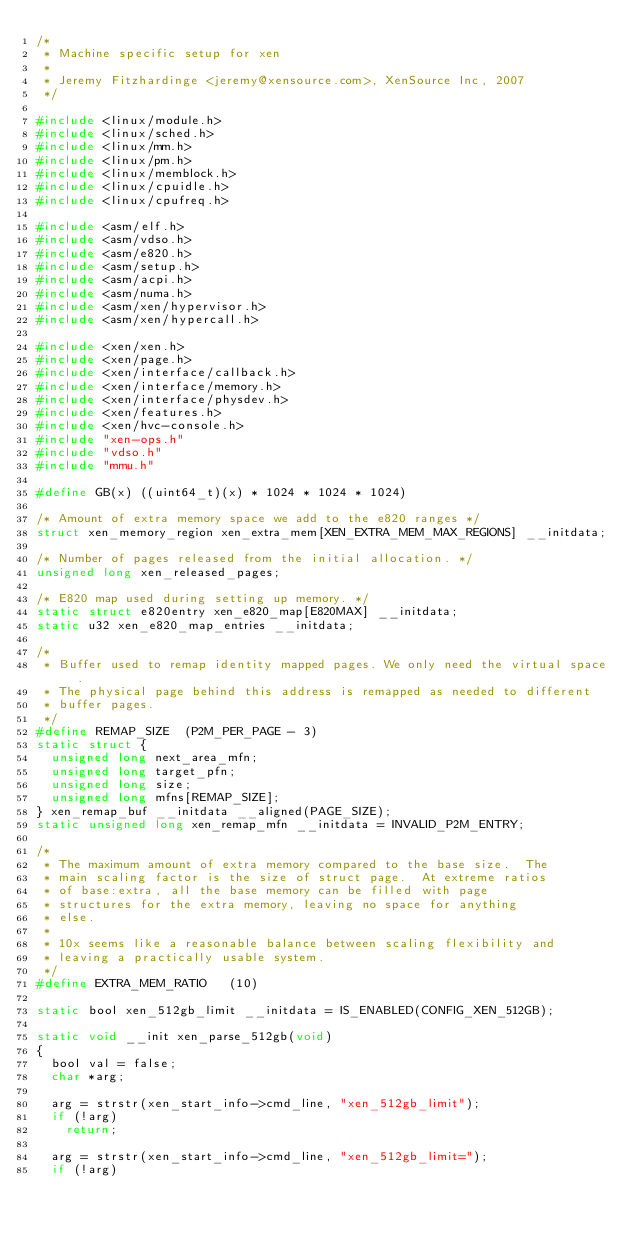Convert code to text. <code><loc_0><loc_0><loc_500><loc_500><_C_>/*
 * Machine specific setup for xen
 *
 * Jeremy Fitzhardinge <jeremy@xensource.com>, XenSource Inc, 2007
 */

#include <linux/module.h>
#include <linux/sched.h>
#include <linux/mm.h>
#include <linux/pm.h>
#include <linux/memblock.h>
#include <linux/cpuidle.h>
#include <linux/cpufreq.h>

#include <asm/elf.h>
#include <asm/vdso.h>
#include <asm/e820.h>
#include <asm/setup.h>
#include <asm/acpi.h>
#include <asm/numa.h>
#include <asm/xen/hypervisor.h>
#include <asm/xen/hypercall.h>

#include <xen/xen.h>
#include <xen/page.h>
#include <xen/interface/callback.h>
#include <xen/interface/memory.h>
#include <xen/interface/physdev.h>
#include <xen/features.h>
#include <xen/hvc-console.h>
#include "xen-ops.h"
#include "vdso.h"
#include "mmu.h"

#define GB(x) ((uint64_t)(x) * 1024 * 1024 * 1024)

/* Amount of extra memory space we add to the e820 ranges */
struct xen_memory_region xen_extra_mem[XEN_EXTRA_MEM_MAX_REGIONS] __initdata;

/* Number of pages released from the initial allocation. */
unsigned long xen_released_pages;

/* E820 map used during setting up memory. */
static struct e820entry xen_e820_map[E820MAX] __initdata;
static u32 xen_e820_map_entries __initdata;

/*
 * Buffer used to remap identity mapped pages. We only need the virtual space.
 * The physical page behind this address is remapped as needed to different
 * buffer pages.
 */
#define REMAP_SIZE	(P2M_PER_PAGE - 3)
static struct {
	unsigned long	next_area_mfn;
	unsigned long	target_pfn;
	unsigned long	size;
	unsigned long	mfns[REMAP_SIZE];
} xen_remap_buf __initdata __aligned(PAGE_SIZE);
static unsigned long xen_remap_mfn __initdata = INVALID_P2M_ENTRY;

/* 
 * The maximum amount of extra memory compared to the base size.  The
 * main scaling factor is the size of struct page.  At extreme ratios
 * of base:extra, all the base memory can be filled with page
 * structures for the extra memory, leaving no space for anything
 * else.
 * 
 * 10x seems like a reasonable balance between scaling flexibility and
 * leaving a practically usable system.
 */
#define EXTRA_MEM_RATIO		(10)

static bool xen_512gb_limit __initdata = IS_ENABLED(CONFIG_XEN_512GB);

static void __init xen_parse_512gb(void)
{
	bool val = false;
	char *arg;

	arg = strstr(xen_start_info->cmd_line, "xen_512gb_limit");
	if (!arg)
		return;

	arg = strstr(xen_start_info->cmd_line, "xen_512gb_limit=");
	if (!arg)</code> 